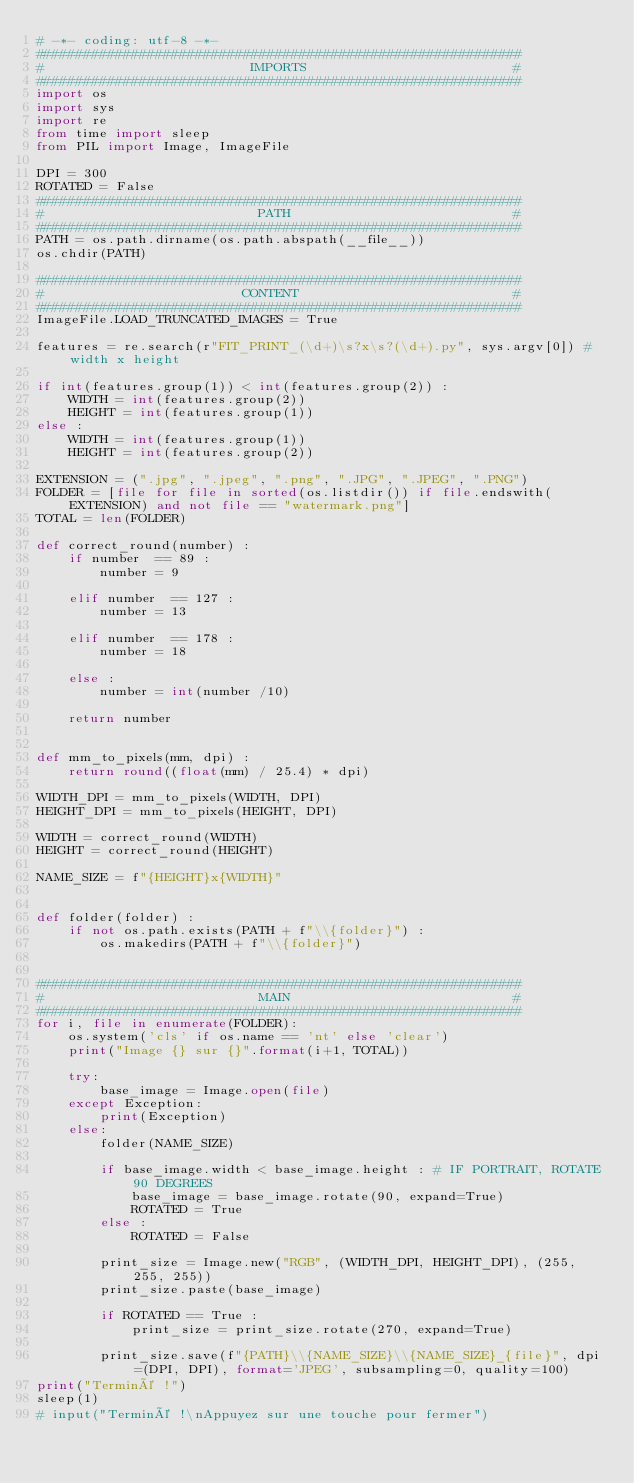<code> <loc_0><loc_0><loc_500><loc_500><_Python_># -*- coding: utf-8 -*-
#############################################################
#                          IMPORTS                          #
#############################################################
import os
import sys
import re
from time import sleep
from PIL import Image, ImageFile

DPI = 300
ROTATED = False
#############################################################
#                           PATH                            #
#############################################################
PATH = os.path.dirname(os.path.abspath(__file__))
os.chdir(PATH)

#############################################################
#                         CONTENT                           #
#############################################################
ImageFile.LOAD_TRUNCATED_IMAGES = True

features = re.search(r"FIT_PRINT_(\d+)\s?x\s?(\d+).py", sys.argv[0]) # width x height

if int(features.group(1)) < int(features.group(2)) :
    WIDTH = int(features.group(2))
    HEIGHT = int(features.group(1))
else :
    WIDTH = int(features.group(1))
    HEIGHT = int(features.group(2))

EXTENSION = (".jpg", ".jpeg", ".png", ".JPG", ".JPEG", ".PNG")
FOLDER = [file for file in sorted(os.listdir()) if file.endswith(EXTENSION) and not file == "watermark.png"]
TOTAL = len(FOLDER)

def correct_round(number) :
    if number  == 89 :
        number = 9
    
    elif number  == 127 :
        number = 13
    
    elif number  == 178 :
        number = 18

    else :
        number = int(number /10)

    return number


def mm_to_pixels(mm, dpi) :
    return round((float(mm) / 25.4) * dpi)

WIDTH_DPI = mm_to_pixels(WIDTH, DPI)
HEIGHT_DPI = mm_to_pixels(HEIGHT, DPI)

WIDTH = correct_round(WIDTH)
HEIGHT = correct_round(HEIGHT)

NAME_SIZE = f"{HEIGHT}x{WIDTH}"


def folder(folder) :
    if not os.path.exists(PATH + f"\\{folder}") :
        os.makedirs(PATH + f"\\{folder}")


#############################################################
#                           MAIN                            #
#############################################################
for i, file in enumerate(FOLDER):
    os.system('cls' if os.name == 'nt' else 'clear')
    print("Image {} sur {}".format(i+1, TOTAL))

    try:
        base_image = Image.open(file)
    except Exception:
        print(Exception)
    else:
        folder(NAME_SIZE)

        if base_image.width < base_image.height : # IF PORTRAIT, ROTATE 90 DEGREES
            base_image = base_image.rotate(90, expand=True)
            ROTATED = True
        else :
            ROTATED = False

        print_size = Image.new("RGB", (WIDTH_DPI, HEIGHT_DPI), (255, 255, 255))
        print_size.paste(base_image)

        if ROTATED == True :
            print_size = print_size.rotate(270, expand=True)
                            
        print_size.save(f"{PATH}\\{NAME_SIZE}\\{NAME_SIZE}_{file}", dpi=(DPI, DPI), format='JPEG', subsampling=0, quality=100)
print("Terminé !")
sleep(1)
# input("Terminé !\nAppuyez sur une touche pour fermer")
</code> 